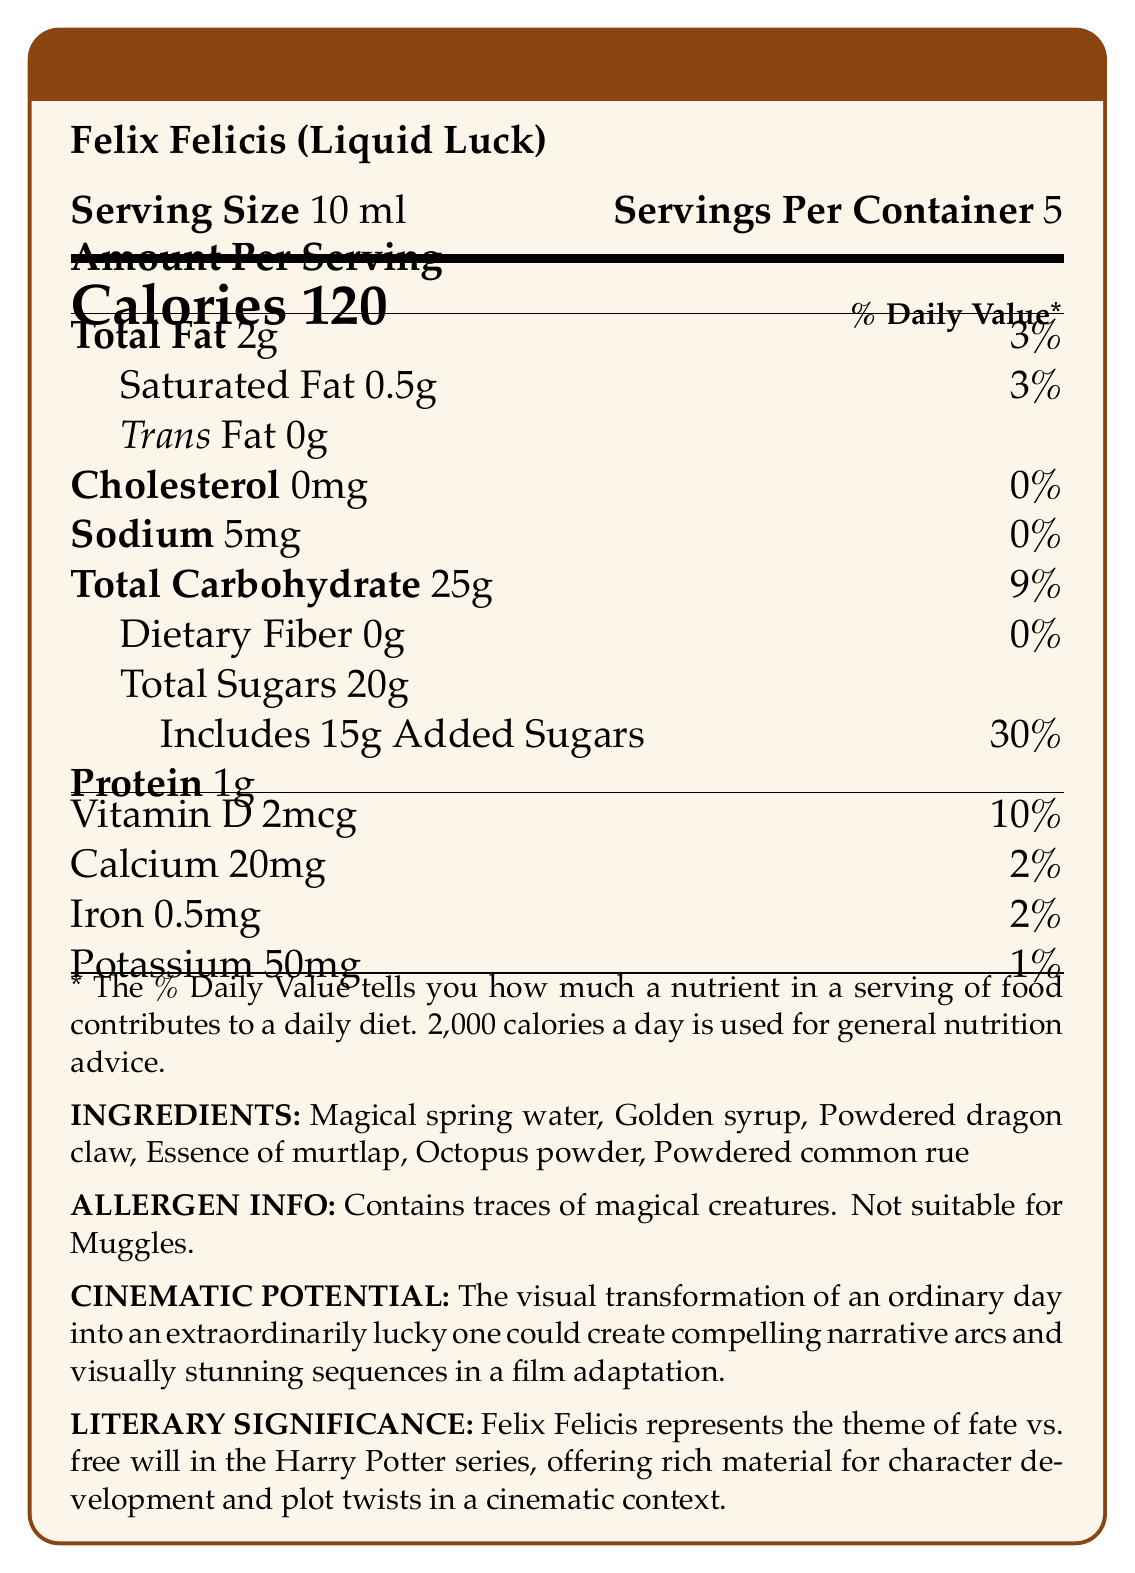what is the serving size of Felix Felicis (Liquid Luck)? The serving size is clearly indicated in the document as "Serving Size 10 ml."
Answer: 10 ml how many grams of total fat are in one serving of Felix Felicis? The amount of total fat per serving is listed as "Total Fat 2g."
Answer: 2g is there any dietary fiber in Felix Felicis? The document specifies "Dietary Fiber 0g," indicating there is no dietary fiber.
Answer: No how many calories are in one container of Felix Felicis? Each serving has 120 calories, and there are 5 servings per container: 120 * 5 = 600 calories.
Answer: 600 calories what ingredients in Felix Felicis might make it unsuitable for Muggles? The allergen information states that it contains traces of magical creatures, making it not suitable for Muggles.
Answer: Contains traces of magical creatures. what is the daily value percentage of added sugars in one serving of Felix Felicis? A) 10% B) 20% C) 30% D) 40% The document lists 30% daily value for added sugars.
Answer: C which of the following is a key theme represented by Felix Felicis in the Harry Potter series? A) Courage B) Fate vs. Free Will C) Love D) Loyalty The document states Felix Felicis represents the theme of fate vs. free will.
Answer: B does Felix Felicis contain any trans fat? The document indicates "Trans Fat 0g," meaning there is no trans fat.
Answer: No describe the main idea of the document. The main idea covers the nutritional specifics, ingredients, allergen concerns, and thematic significance related to a fictional potion from the Harry Potter series.
Answer: The document provides detailed nutritional information about a potion called Felix Felicis (Liquid Luck), including serving size, calories, macronutrients, vitamins, and ingredients. It also highlights allergen information, the potion's cinematic potential, and its literary significance in the Harry Potter series. can Felix Felicis be safely consumed by someone with a muggle background? The allergen information clearly states that it is not suitable for Muggles.
Answer: No what amount of cholesterol is present in a serving of Felix Felicis? The document specifies "Cholesterol 0mg," indicating no cholesterol.
Answer: 0mg which vitamin is present in the highest daily value percentage? Vitamin D has the highest daily value percentage at 10%.
Answer: Vitamin D how much protein does Felix Felicis contain? The protein content is listed as "Protein 1g."
Answer: 1g can you determine the exact amount of powdered dragon claw in Felix Felicis from the document? The document lists powdered dragon claw as an ingredient but does not provide the exact amount.
Answer: Not enough information 